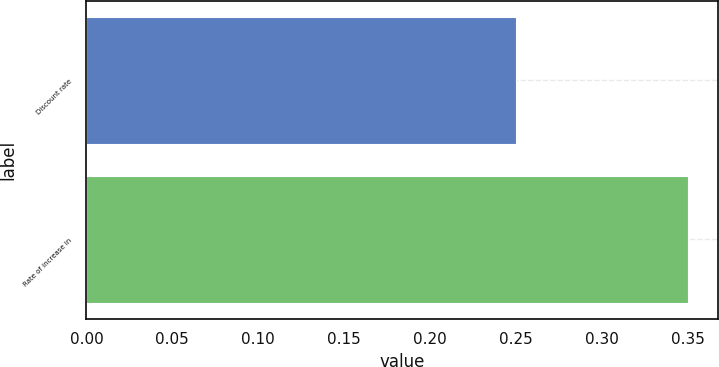Convert chart. <chart><loc_0><loc_0><loc_500><loc_500><bar_chart><fcel>Discount rate<fcel>Rate of increase in<nl><fcel>0.25<fcel>0.35<nl></chart> 